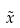<formula> <loc_0><loc_0><loc_500><loc_500>\tilde { x }</formula> 